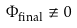<formula> <loc_0><loc_0><loc_500><loc_500>\Phi _ { \text {final} } \not \equiv 0</formula> 